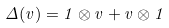<formula> <loc_0><loc_0><loc_500><loc_500>\Delta ( v ) = 1 \otimes v + v \otimes 1</formula> 